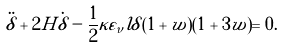Convert formula to latex. <formula><loc_0><loc_0><loc_500><loc_500>\ddot { \delta } + 2 H \dot { \delta } - \frac { 1 } { 2 } \kappa \varepsilon _ { \nu } l \delta ( 1 + w ) ( 1 + 3 w ) = 0 .</formula> 